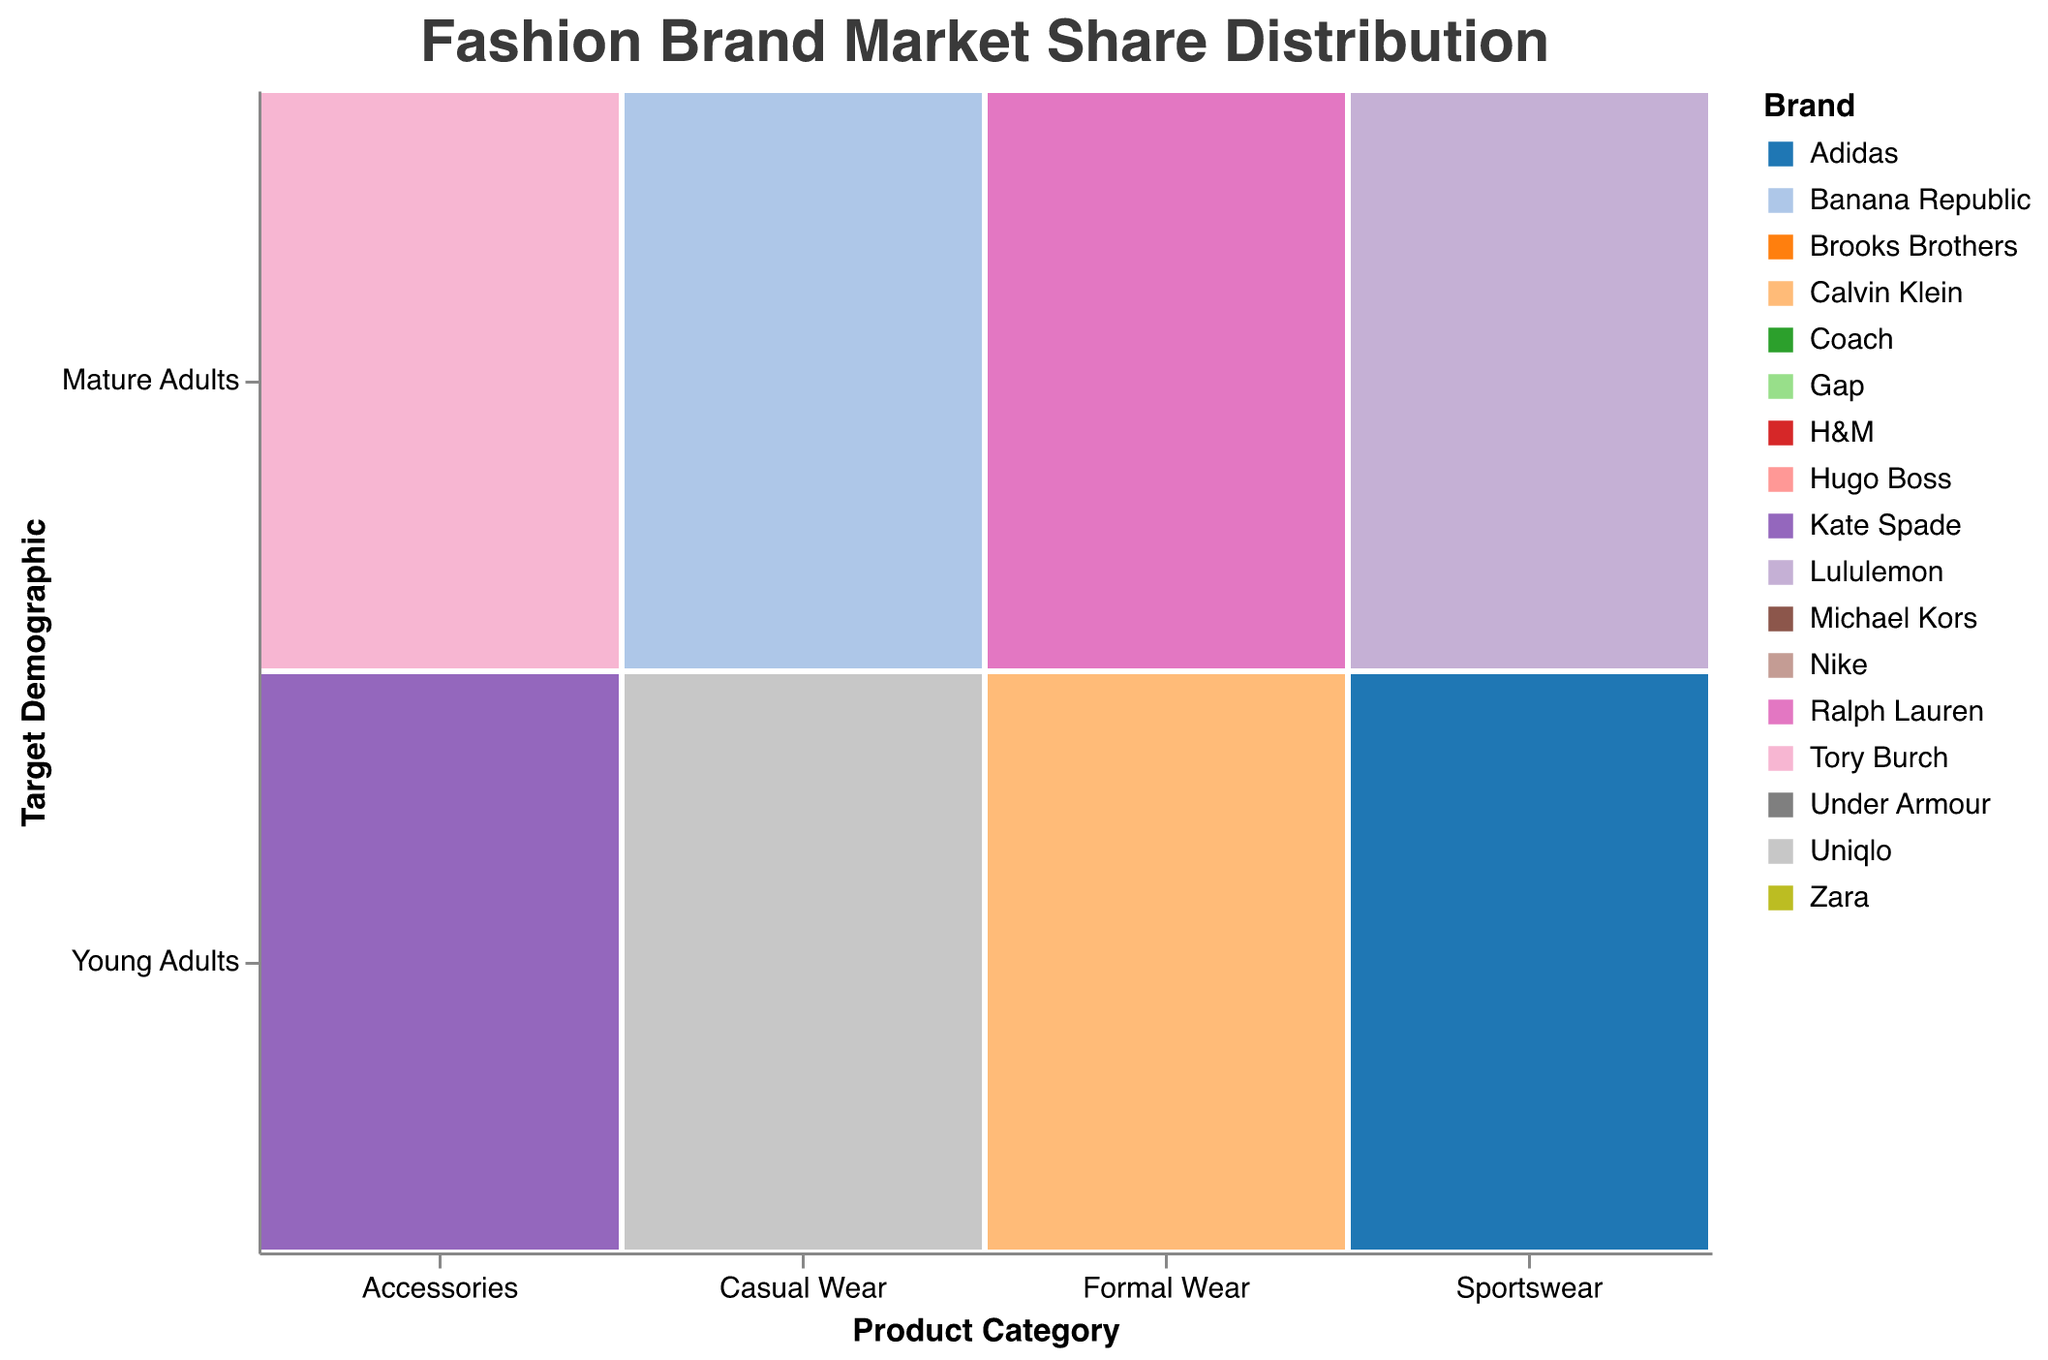What is the title of the figure? The title of the figure is located at the top and is designed to provide a clear understanding of the content being displayed.
Answer: Fashion Brand Market Share Distribution Which brand has the highest market share in the Sportswear category for Young Adults? In the mosaic plot, observe the section corresponding to Sportswear for Young Adults. The brand with the largest rectangle (representing the largest market share) is noted.
Answer: Nike How does the market share of H&M for Young Adults in Casual Wear compare to the market share of Zara for the same group and category? Compare the sizes of the rectangles representing H&M and Zara within the Casual Wear category for Young Adults. H&M has a market share of 25, while Zara has a market share of 20.
Answer: H&M has a higher market share than Zara Which product category appears to have the most diverse brands? Look at the distribution of rectangles within each product category. The category with the most brands represented indicates the highest diversity.
Answer: Casual Wear What is the combined market share for brands in the Formal Wear category targeting Mature Adults? Sum the market shares of Brooks Brothers and Ralph Lauren within the Formal Wear category for Mature Adults. 20 (Brooks Brothers) + 25 (Ralph Lauren) = 45.
Answer: 45 What is the overall market share of brands targeting Young Adults in the Accessories category? Add the market shares for Michael Kors and Kate Spade in the Accessories category for Young Adults. 15 (Michael Kors) + 12 (Kate Spade) = 27.
Answer: 27 Which brand has the lowest market share in the Accessories category for Mature Adults? Identify the smallest rectangle in the Accessories category for Mature Adults.
Answer: Tory Burch Compare the highest market shares of brands in the Sportswear category for both target demographics. Look at the largest rectangles in the Sportswear category for Young Adults (Nike with 30) and Mature Adults (Lululemon with 20).
Answer: Nike for Young Adults has the highest What is the average market share for the brands in the Formal Wear category targeting Young Adults? Calculate the average by adding the market shares of Hugo Boss and Calvin Klein and then dividing by the number of brands. (22 + 18) / 2 = 20.
Answer: 20 Which product category has the smallest combined market share for Mature Adults? Sum the market shares for all brands in each product category for Mature Adults and identify the smallest sum. The categories are Accessories (18 + 14 = 32), Casual Wear (18 + 12 = 30), Formal Wear (20 + 25 = 45), Sportswear (15 + 20 = 35).
Answer: Casual Wear 